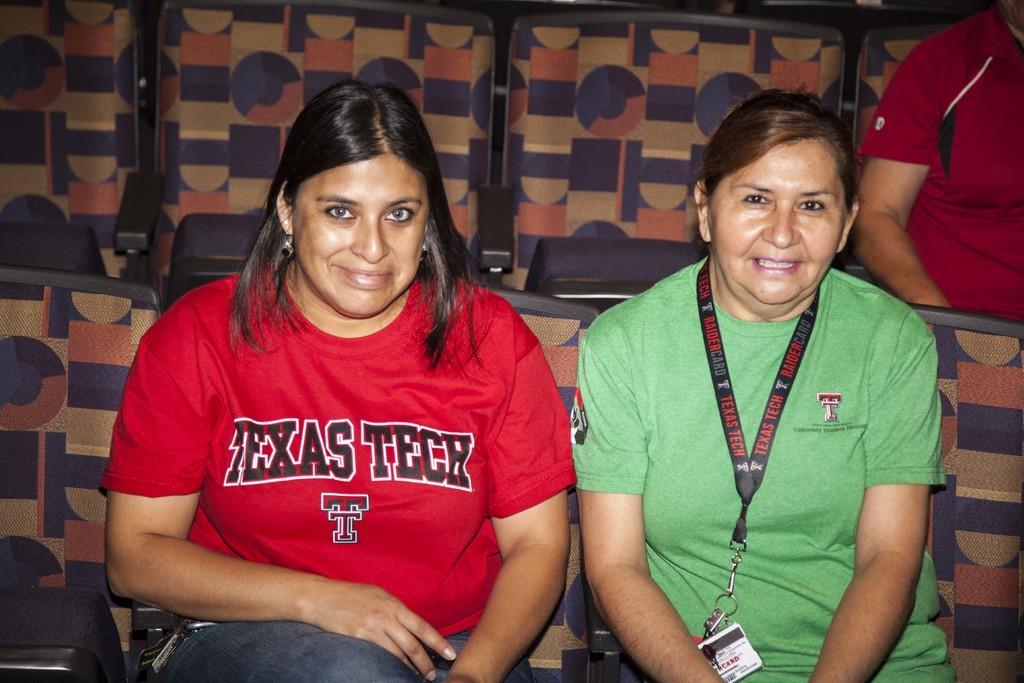Please provide a concise description of this image. In this image I can see three people are sitting on the chairs. I can see these people are wearing the red and green color dresses. I can see one person with the identification card. 